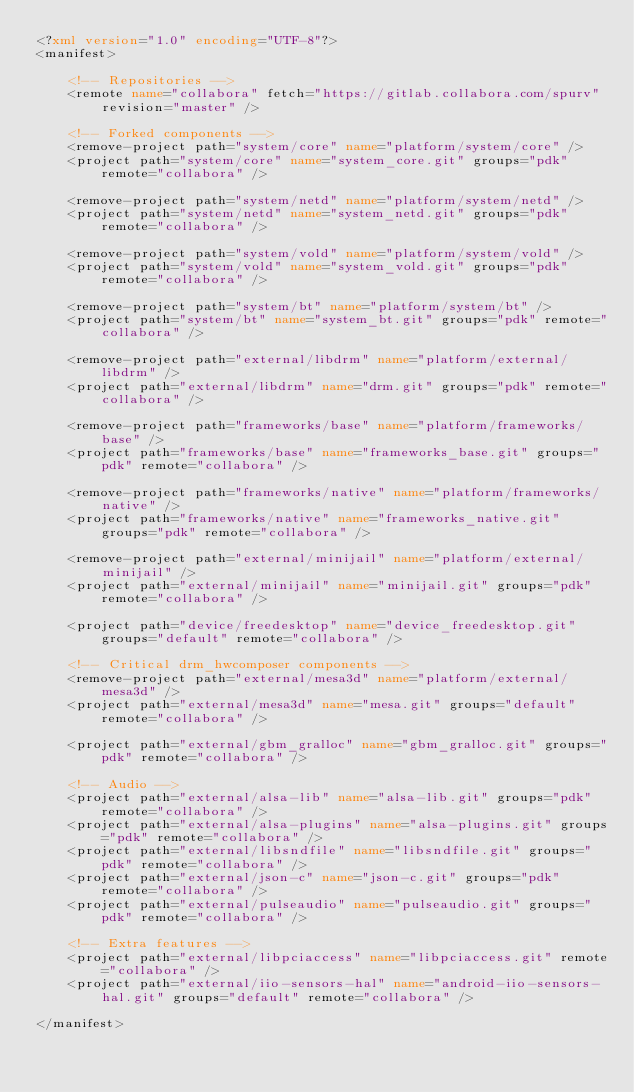<code> <loc_0><loc_0><loc_500><loc_500><_XML_><?xml version="1.0" encoding="UTF-8"?>
<manifest>

	<!-- Repositories -->
	<remote name="collabora" fetch="https://gitlab.collabora.com/spurv" revision="master" />

	<!-- Forked components -->
	<remove-project path="system/core" name="platform/system/core" />
	<project path="system/core" name="system_core.git" groups="pdk" remote="collabora" />

	<remove-project path="system/netd" name="platform/system/netd" />
	<project path="system/netd" name="system_netd.git" groups="pdk" remote="collabora" />

	<remove-project path="system/vold" name="platform/system/vold" />
	<project path="system/vold" name="system_vold.git" groups="pdk" remote="collabora" />

	<remove-project path="system/bt" name="platform/system/bt" />
	<project path="system/bt" name="system_bt.git" groups="pdk" remote="collabora" />

	<remove-project path="external/libdrm" name="platform/external/libdrm" />
	<project path="external/libdrm" name="drm.git" groups="pdk" remote="collabora" />

	<remove-project path="frameworks/base" name="platform/frameworks/base" />
	<project path="frameworks/base" name="frameworks_base.git" groups="pdk" remote="collabora" />

	<remove-project path="frameworks/native" name="platform/frameworks/native" />
	<project path="frameworks/native" name="frameworks_native.git" groups="pdk" remote="collabora" />

	<remove-project path="external/minijail" name="platform/external/minijail" />
	<project path="external/minijail" name="minijail.git" groups="pdk" remote="collabora" />

	<project path="device/freedesktop" name="device_freedesktop.git" groups="default" remote="collabora" />

	<!-- Critical drm_hwcomposer components -->
	<remove-project path="external/mesa3d" name="platform/external/mesa3d" />
	<project path="external/mesa3d" name="mesa.git" groups="default" remote="collabora" />

	<project path="external/gbm_gralloc" name="gbm_gralloc.git" groups="pdk" remote="collabora" />

	<!-- Audio -->
	<project path="external/alsa-lib" name="alsa-lib.git" groups="pdk" remote="collabora" />
	<project path="external/alsa-plugins" name="alsa-plugins.git" groups="pdk" remote="collabora" />
	<project path="external/libsndfile" name="libsndfile.git" groups="pdk" remote="collabora" />
	<project path="external/json-c" name="json-c.git" groups="pdk" remote="collabora" />
	<project path="external/pulseaudio" name="pulseaudio.git" groups="pdk" remote="collabora" />

	<!-- Extra features -->
	<project path="external/libpciaccess" name="libpciaccess.git" remote="collabora" />
	<project path="external/iio-sensors-hal" name="android-iio-sensors-hal.git" groups="default" remote="collabora" />

</manifest>
</code> 